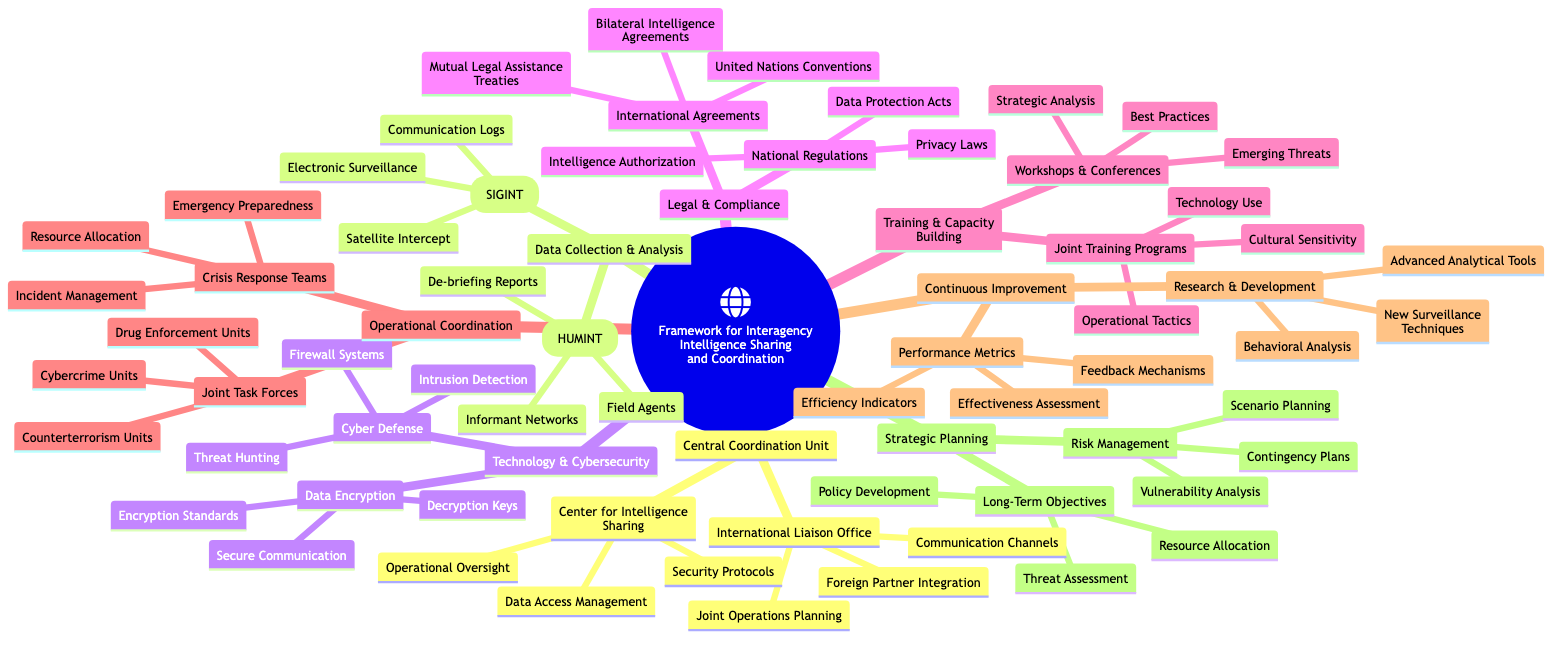What are the main components of the framework? The framework contains key components such as Central Coordination Unit, Data Collection & Analysis, Technology & Cybersecurity, Legal & Compliance, Training & Capacity Building, Operational Coordination, Continuous Improvement, and Strategic Planning. Each of these components can be found as first-level nodes in the mind map.
Answer: Central Coordination Unit, Data Collection & Analysis, Technology & Cybersecurity, Legal & Compliance, Training & Capacity Building, Operational Coordination, Continuous Improvement, Strategic Planning How many areas are under Technology & Cybersecurity? Under Technology & Cybersecurity, there are two areas listed: Cyber Defense and Data Encryption. By counting these two specific nodes, you can determine the answer directly.
Answer: 2 Which unit is responsible for operational oversight in the Central Coordination Unit? Within the Central Coordination Unit, the Center for Intelligence Sharing is responsible for operational oversight, as indicated in the sub-nodes of this component.
Answer: Center for Intelligence Sharing What type of intelligence is collected under Data Collection & Analysis? Data Collection & Analysis includes two types of intelligence: Human Intelligence (HUMINT) and Signals Intelligence (SIGINT). These are clearly noted as the primary categories in that section of the mind map.
Answer: Human Intelligence (HUMINT), Signals Intelligence (SIGINT) What are the focus areas of Joint Training Programs? The Joint Training Programs focus on Operational Tactics, Cultural Sensitivity, and Technology Use, which are explicitly listed as sub-areas under this section of the Training & Capacity Building component.
Answer: Operational Tactics, Cultural Sensitivity, Technology Use What is the purpose of the International Liaison Office? The International Liaison Office serves to enhance Foreign Partner Integration, maintain Communication Channels, and facilitate Joint Operations Planning, all of which are outlined as its key responsibilities.
Answer: Foreign Partner Integration, Communication Channels, Joint Operations Planning How many performance metrics are mentioned under Continuous Improvement? Under Continuous Improvement, three performance metrics are specified: Efficiency Indicators, Effectiveness Assessment, and Feedback Mechanisms. Summing these up leads to the answer.
Answer: 3 What types of units are included in Joint Task Forces? The Joint Task Forces consist of Counterterrorism Units, Cybercrime Units, and Drug Enforcement Units, as specifically listed in the Operational Coordination section of the mind map.
Answer: Counterterrorism Units, Cybercrime Units, Drug Enforcement Units What legal framework governs interagency cooperation? The legal framework includes National Regulations and International Agreements, which are the two main categories highlighted in the Legal & Compliance section that govern interagency collaboration and sharing.
Answer: National Regulations, International Agreements 